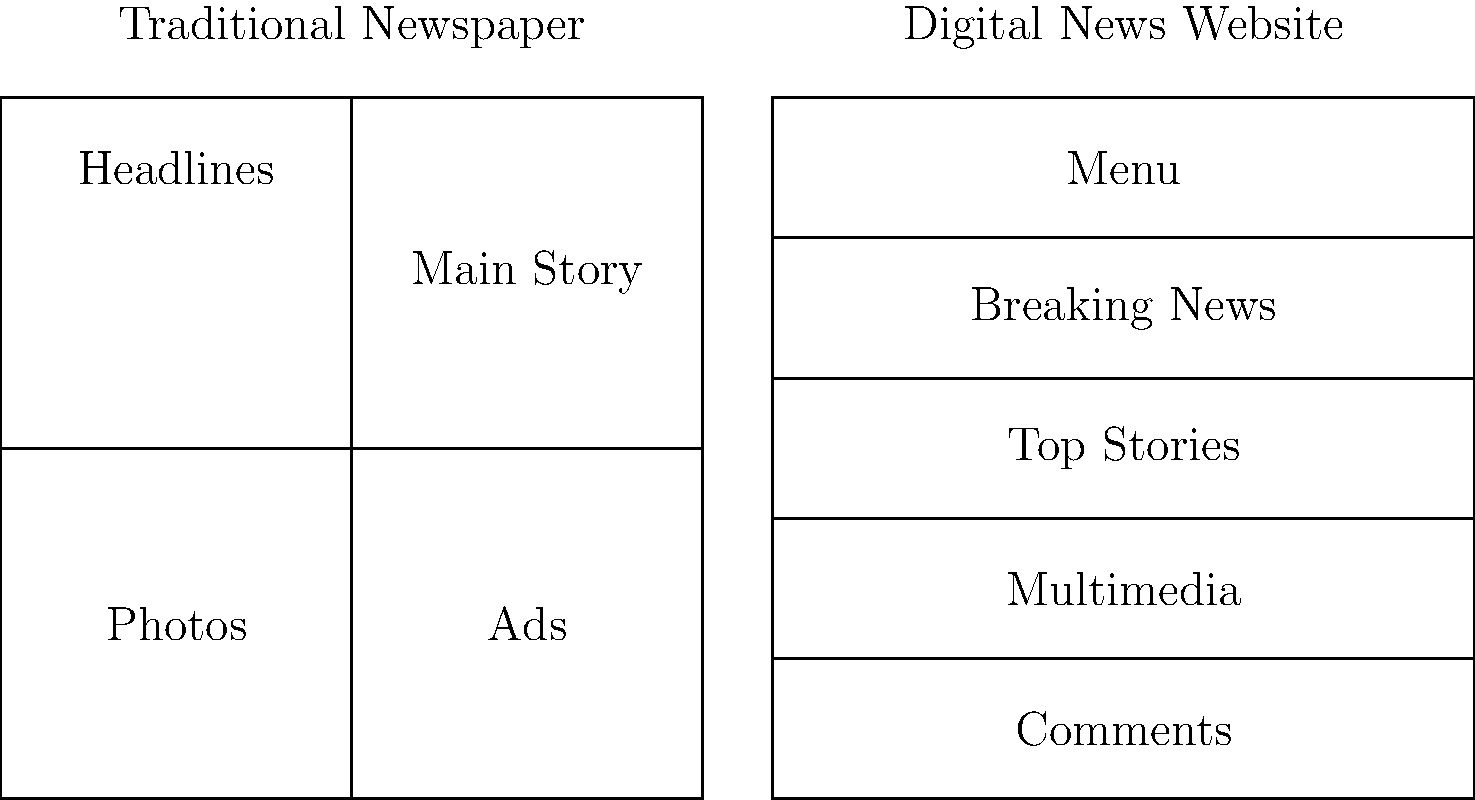Based on the side-by-side diagrams comparing a traditional print newspaper layout with a modern digital news website, which feature is prominently displayed at the top of the digital layout but is typically not found in the same position on a print newspaper? Let's analyze the layouts step-by-step:

1. Traditional Newspaper Layout (left side):
   - Top section: Headlines
   - Middle-right: Main Story
   - Bottom-left: Photos
   - Bottom-right: Ads

2. Digital News Website Layout (right side):
   - Top section: Menu
   - Second section: Breaking News
   - Third section: Top Stories
   - Fourth section: Multimedia
   - Bottom section: Comments

3. Key differences:
   - The digital layout is more segmented horizontally
   - The traditional layout has a more varied structure

4. Focusing on the top section:
   - Traditional newspaper: Headlines
   - Digital website: Menu

5. The menu is a navigational feature that allows users to access different sections of the website quickly. This is a digital-specific element that doesn't have a direct equivalent in print newspapers.

6. In contrast, headlines in a print newspaper are typically spread across the front page, not confined to a specific bar at the top.

Therefore, the menu is the feature prominently displayed at the top of the digital layout but not found in the same position on a print newspaper.
Answer: Menu 